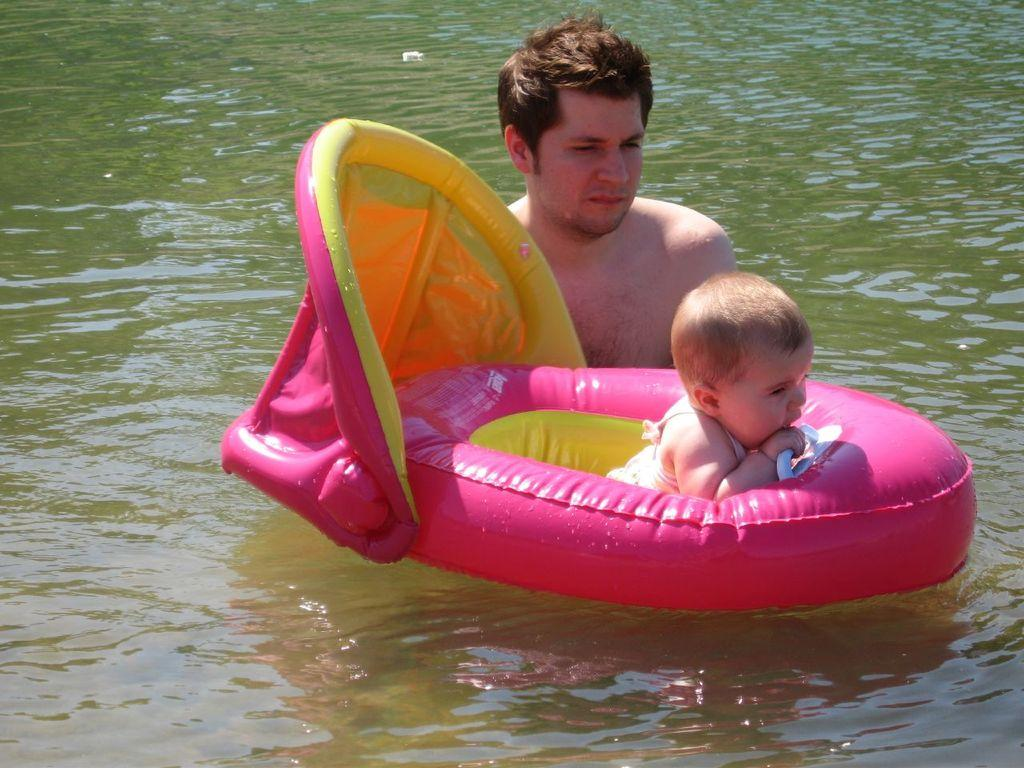What is the main subject of the image? The main subject of the image is an infant. Where is the infant located in the image? The infant is sitting in a baby float. Can you describe the person behind the infant? There is a man behind the infant, and he is looking at the infant. What type of vegetable is being sold at the market in the image? There is no market or vegetable present in the image; it features an infant in a baby float with a man behind them. 